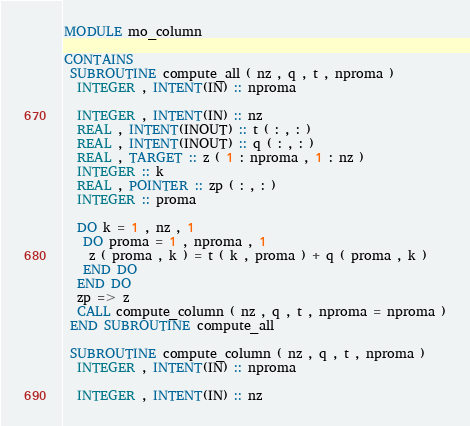Convert code to text. <code><loc_0><loc_0><loc_500><loc_500><_FORTRAN_>MODULE mo_column

CONTAINS
 SUBROUTINE compute_all ( nz , q , t , nproma )
  INTEGER , INTENT(IN) :: nproma

  INTEGER , INTENT(IN) :: nz
  REAL , INTENT(INOUT) :: t ( : , : )
  REAL , INTENT(INOUT) :: q ( : , : )
  REAL , TARGET :: z ( 1 : nproma , 1 : nz )
  INTEGER :: k
  REAL , POINTER :: zp ( : , : )
  INTEGER :: proma

  DO k = 1 , nz , 1
   DO proma = 1 , nproma , 1
    z ( proma , k ) = t ( k , proma ) + q ( proma , k )
   END DO
  END DO
  zp => z
  CALL compute_column ( nz , q , t , nproma = nproma )
 END SUBROUTINE compute_all

 SUBROUTINE compute_column ( nz , q , t , nproma )
  INTEGER , INTENT(IN) :: nproma

  INTEGER , INTENT(IN) :: nz</code> 